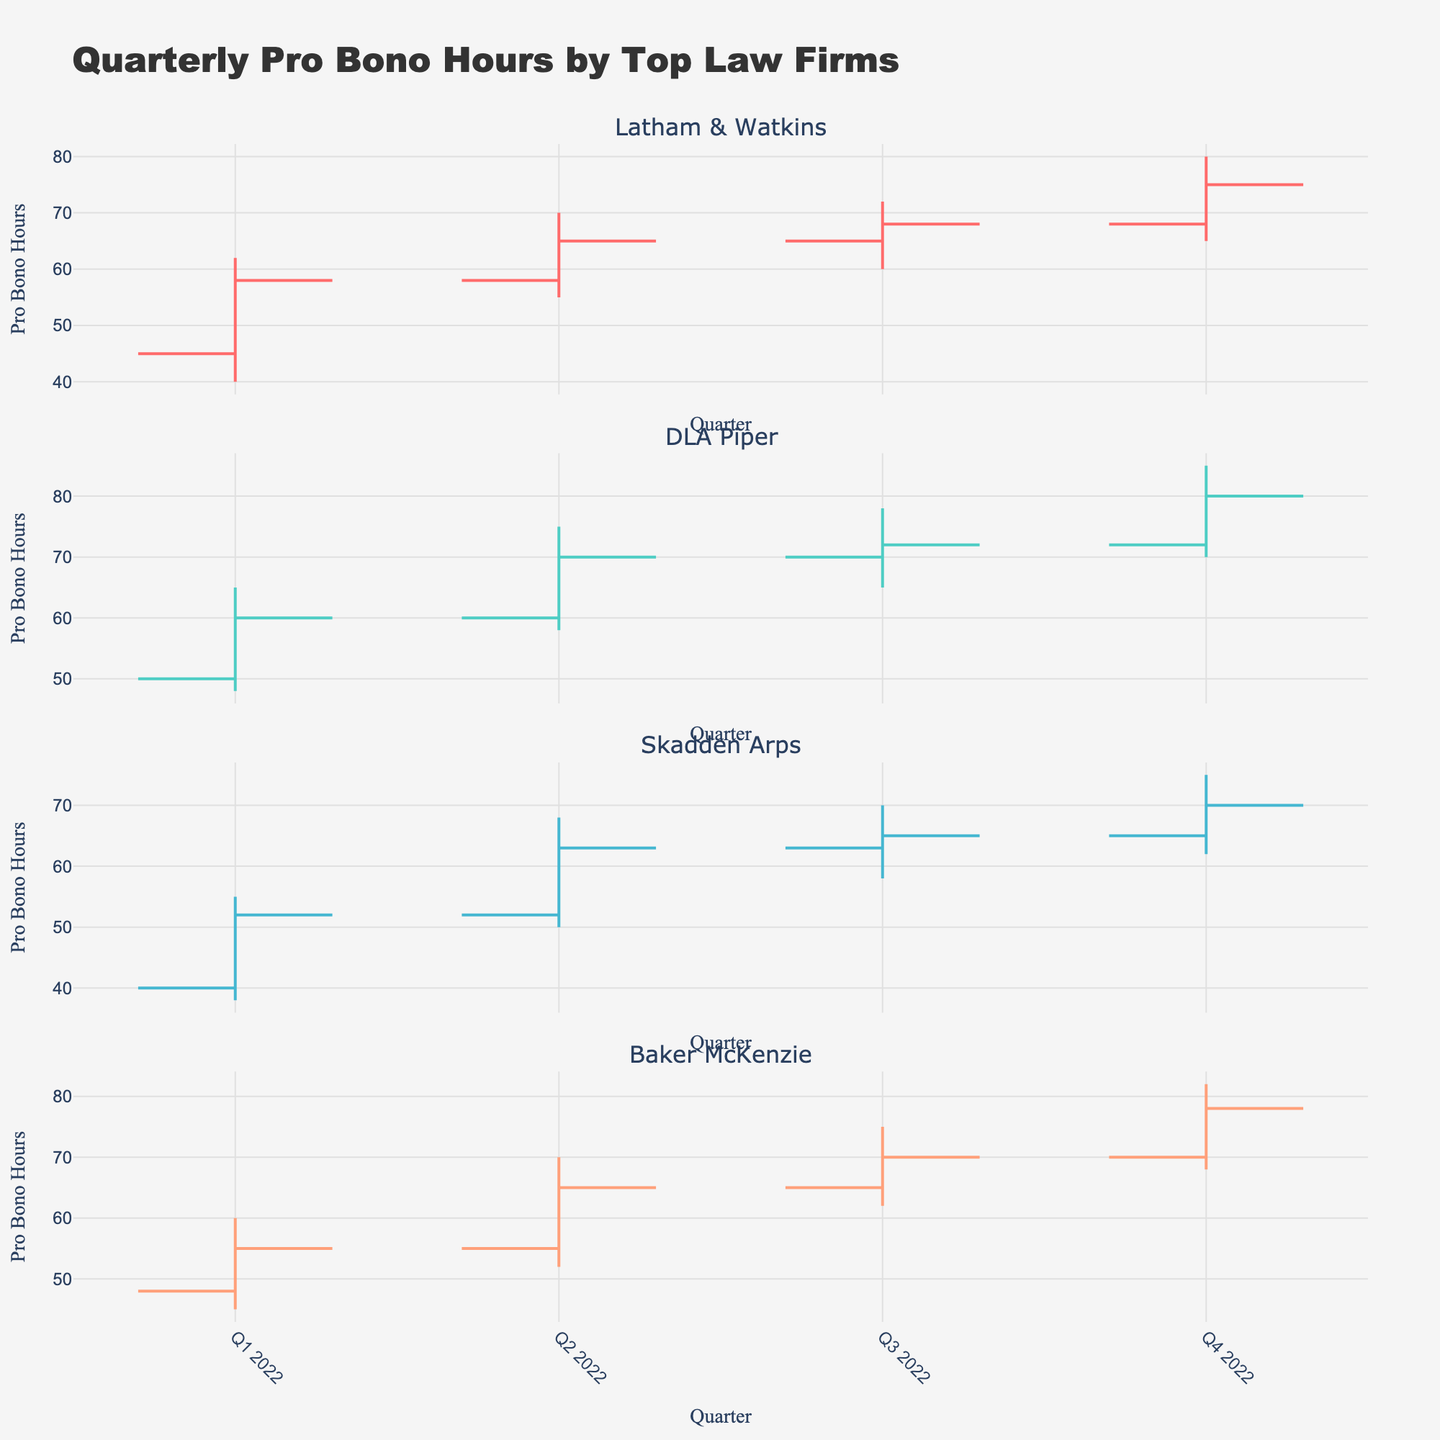What's the title of the figure? The title of the figure is prominently displayed at the top, so you can simply read it.
Answer: Quarterly Pro Bono Hours by Top Law Firms How many law firms are compared in the figure? The number of subplots represents the number of law firms compared. By counting the subplot titles, we can determine the number.
Answer: Four Which law firm had the highest closing pro bono hours in Q4 2022? Look at the 'Close' price for each law firm in Q4 2022 and compare their values. Latham & Watkins closed at 75, DLA Piper at 80, Skadden Arps at 70, and Baker McKenzie at 78.
Answer: DLA Piper What was Baker McKenzie's lowest pro bono hour contribution in the given quarters? The lowest value in the 'Low' column for Baker McKenzie is the answer. For Baker McKenzie, the lowest values are 45, 52, 62, and 68, so the lowest is 45.
Answer: 45 Which firm showed an overall increasing trend in pro bono hours each quarter? By examining each firm's 'Close' values across quarters, we can determine if there is a consistent increase. DLA Piper and Baker McKenzie both show increasing trends, but we need to pick one firm. After comparison: 
Latham & Watkins (58 -> 65 -> 68 -> 75), DLA Piper (60 -> 70 -> 72 -> 80), Skadden Arps (52 -> 63 -> 65 -> 70), and Baker McKenzie (55 -> 65 -> 70 -> 78).
Answer: Latham & Watkins, DLA Piper, Baker McKenzie What is the average high pro bono hours of Skadden Arps across the four quarters? Sum the 'High' values for Skadden Arps and divide by 4. (55 + 68 + 70 + 75) / 4 = 67.
Answer: 67 Comparing DLA Piper and Baker McKenzie in Q3 2022, who had the higher 'High' pro bono hours? Look at the 'High' values for both firms in Q3 2022. DLA Piper had 78, and Baker McKenzie had 75.
Answer: DLA Piper By how much did Latham & Watkins' closing pro bono hours increase from Q1 2022 to Q4 2022? Subtract the closing value in Q1 2022 from that in Q4 2022. 75 - 58 = 17.
Answer: 17 